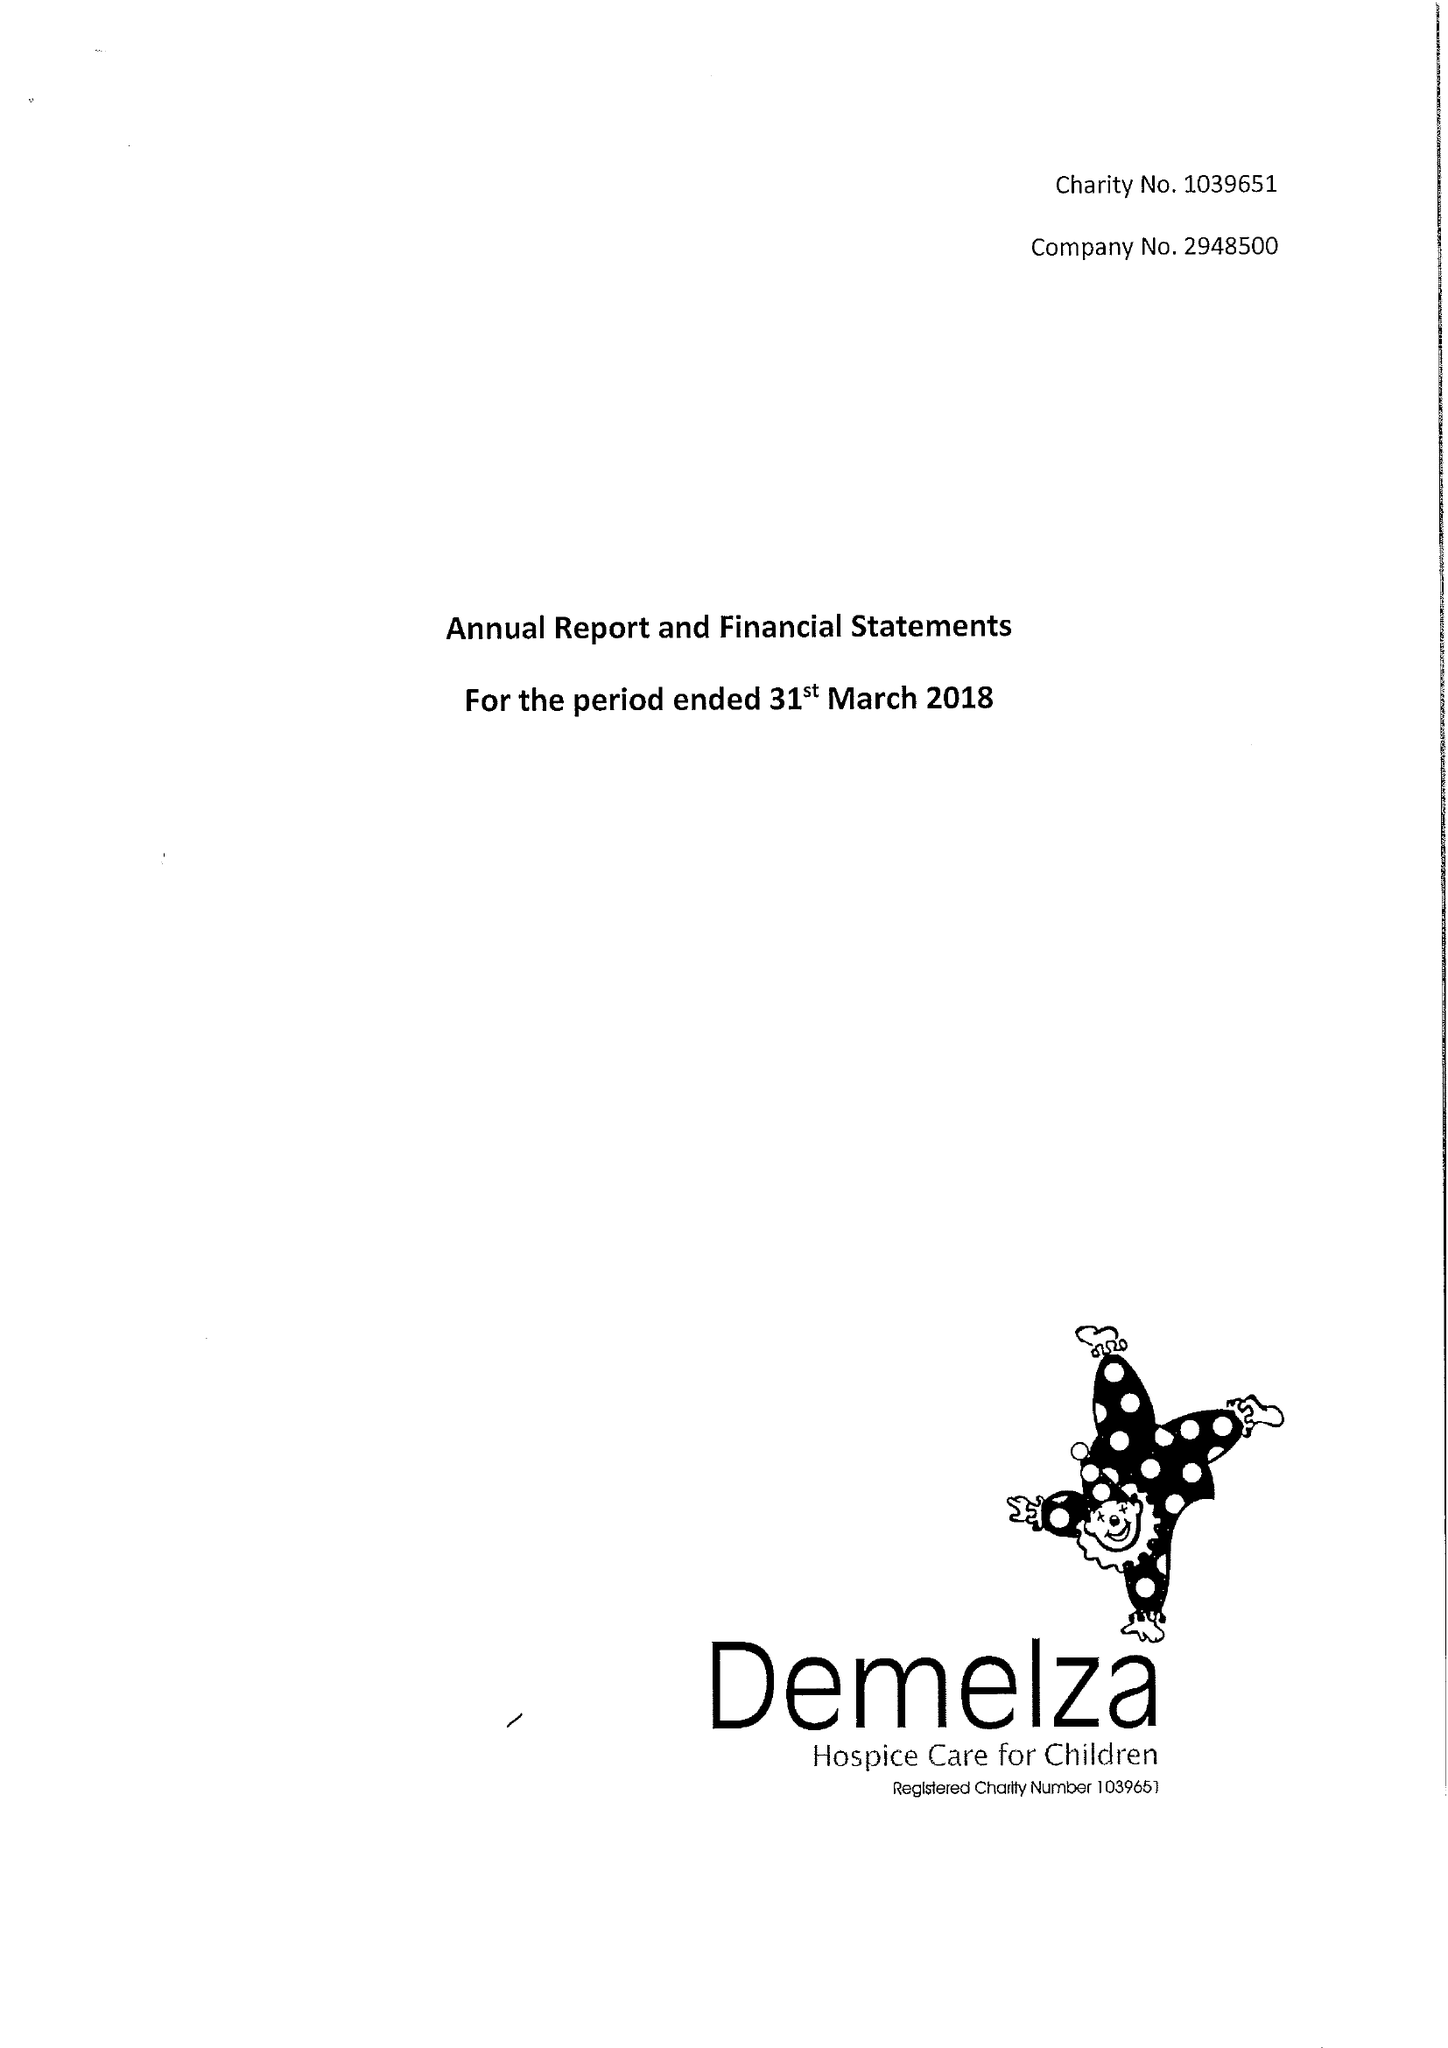What is the value for the income_annually_in_british_pounds?
Answer the question using a single word or phrase. 14132501.00 